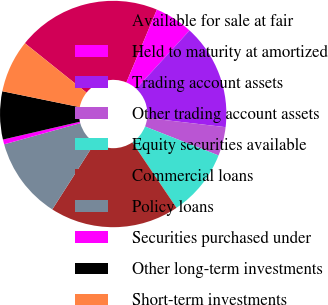<chart> <loc_0><loc_0><loc_500><loc_500><pie_chart><fcel>Available for sale at fair<fcel>Held to maturity at amortized<fcel>Trading account assets<fcel>Other trading account assets<fcel>Equity securities available<fcel>Commercial loans<fcel>Policy loans<fcel>Securities purchased under<fcel>Other long-term investments<fcel>Short-term investments<nl><fcel>20.55%<fcel>5.48%<fcel>15.07%<fcel>4.11%<fcel>9.59%<fcel>18.49%<fcel>11.64%<fcel>0.69%<fcel>6.85%<fcel>7.53%<nl></chart> 